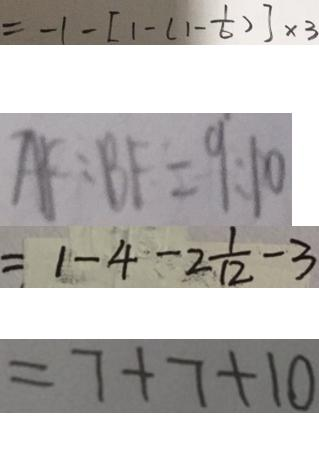Convert formula to latex. <formula><loc_0><loc_0><loc_500><loc_500>= - 1 - [ 1 - ( 1 - \frac { 1 } { 6 } ) ] \times 3 
 A F : B F = 9 : 1 0 
 = 1 - 4 - 2 \frac { 1 } { 1 2 } - 3 
 = 7 + 7 + 1 0</formula> 